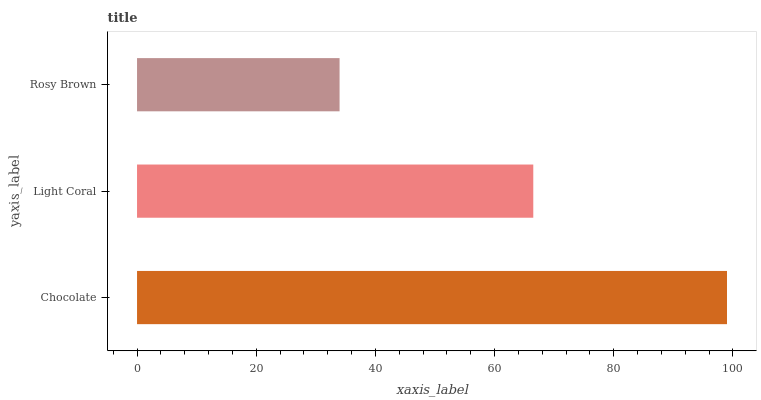Is Rosy Brown the minimum?
Answer yes or no. Yes. Is Chocolate the maximum?
Answer yes or no. Yes. Is Light Coral the minimum?
Answer yes or no. No. Is Light Coral the maximum?
Answer yes or no. No. Is Chocolate greater than Light Coral?
Answer yes or no. Yes. Is Light Coral less than Chocolate?
Answer yes or no. Yes. Is Light Coral greater than Chocolate?
Answer yes or no. No. Is Chocolate less than Light Coral?
Answer yes or no. No. Is Light Coral the high median?
Answer yes or no. Yes. Is Light Coral the low median?
Answer yes or no. Yes. Is Rosy Brown the high median?
Answer yes or no. No. Is Chocolate the low median?
Answer yes or no. No. 